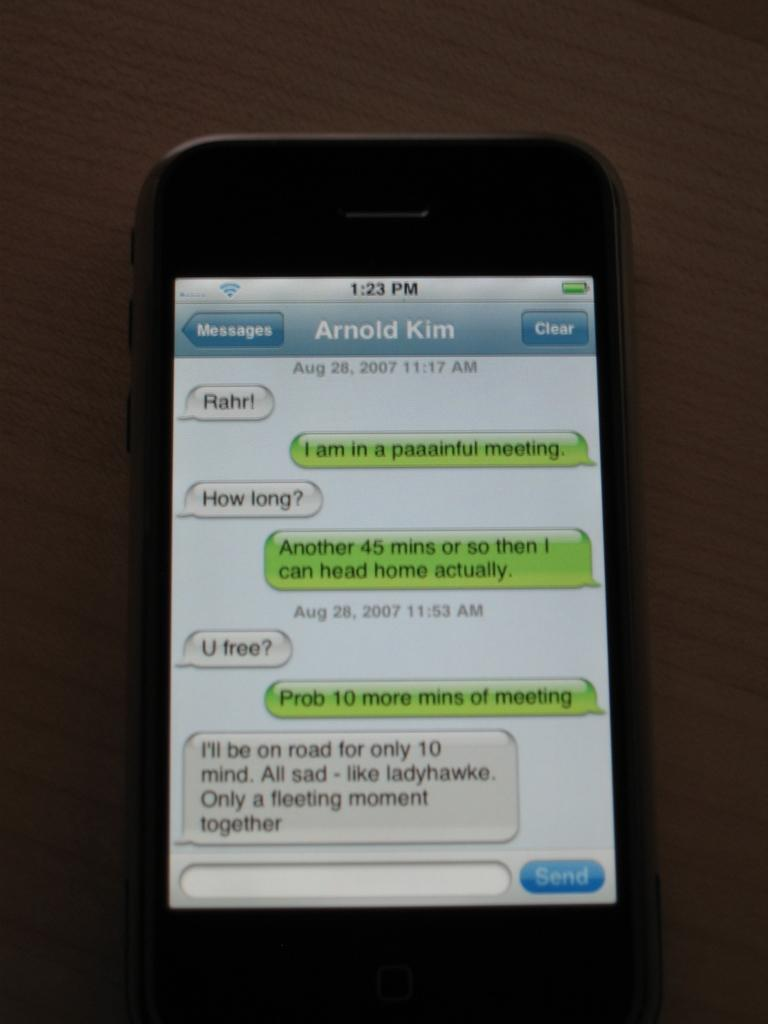<image>
Write a terse but informative summary of the picture. A phone showing messages to and from Arnold Kim. 